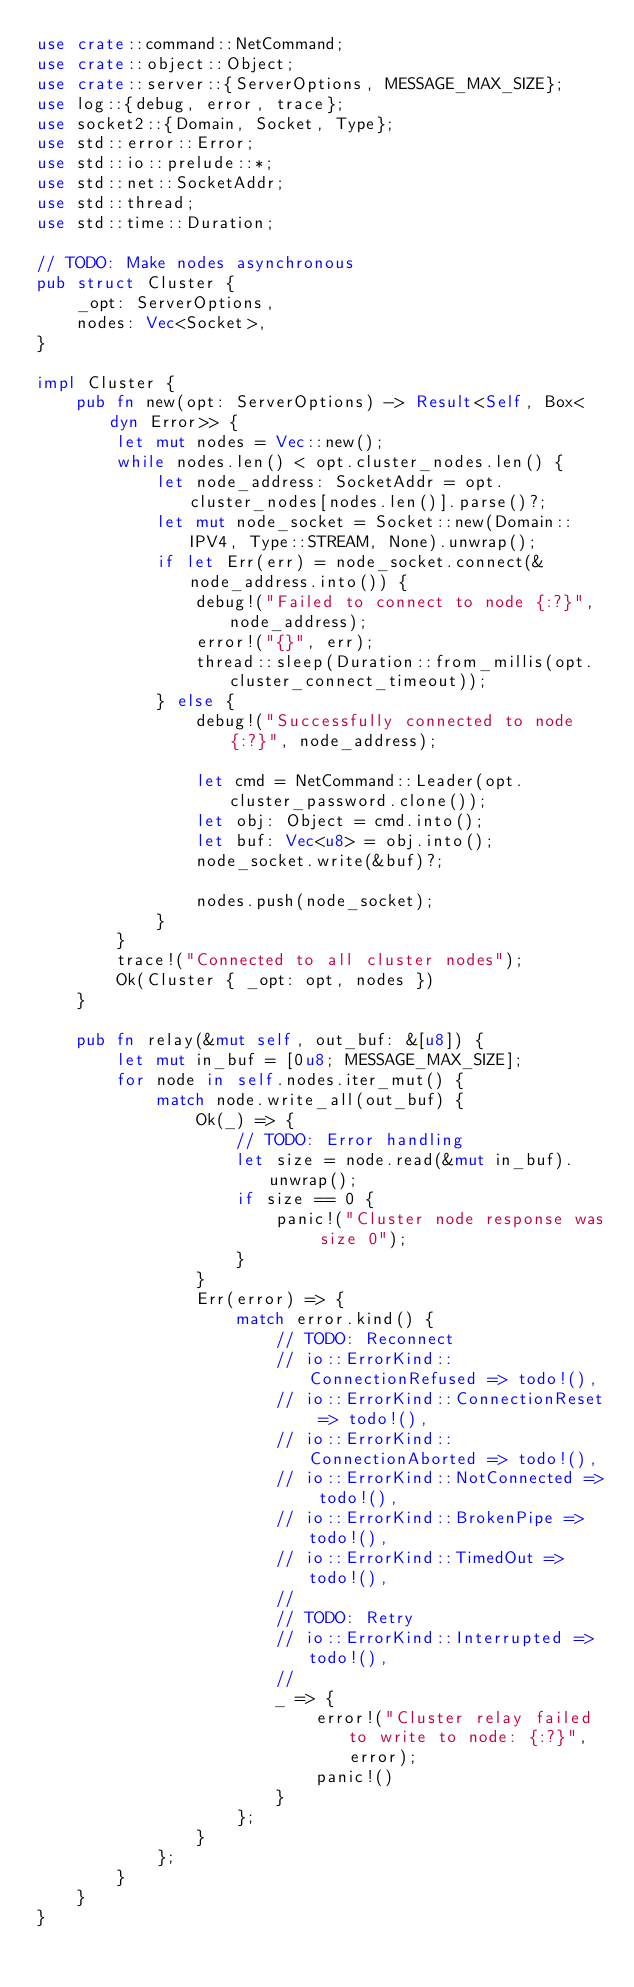Convert code to text. <code><loc_0><loc_0><loc_500><loc_500><_Rust_>use crate::command::NetCommand;
use crate::object::Object;
use crate::server::{ServerOptions, MESSAGE_MAX_SIZE};
use log::{debug, error, trace};
use socket2::{Domain, Socket, Type};
use std::error::Error;
use std::io::prelude::*;
use std::net::SocketAddr;
use std::thread;
use std::time::Duration;

// TODO: Make nodes asynchronous
pub struct Cluster {
    _opt: ServerOptions,
    nodes: Vec<Socket>,
}

impl Cluster {
    pub fn new(opt: ServerOptions) -> Result<Self, Box<dyn Error>> {
        let mut nodes = Vec::new();
        while nodes.len() < opt.cluster_nodes.len() {
            let node_address: SocketAddr = opt.cluster_nodes[nodes.len()].parse()?;
            let mut node_socket = Socket::new(Domain::IPV4, Type::STREAM, None).unwrap();
            if let Err(err) = node_socket.connect(&node_address.into()) {
                debug!("Failed to connect to node {:?}", node_address);
                error!("{}", err);
                thread::sleep(Duration::from_millis(opt.cluster_connect_timeout));
            } else {
                debug!("Successfully connected to node {:?}", node_address);

                let cmd = NetCommand::Leader(opt.cluster_password.clone());
                let obj: Object = cmd.into();
                let buf: Vec<u8> = obj.into();
                node_socket.write(&buf)?;

                nodes.push(node_socket);
            }
        }
        trace!("Connected to all cluster nodes");
        Ok(Cluster { _opt: opt, nodes })
    }

    pub fn relay(&mut self, out_buf: &[u8]) {
        let mut in_buf = [0u8; MESSAGE_MAX_SIZE];
        for node in self.nodes.iter_mut() {
            match node.write_all(out_buf) {
                Ok(_) => {
                    // TODO: Error handling
                    let size = node.read(&mut in_buf).unwrap();
                    if size == 0 {
                        panic!("Cluster node response was size 0");
                    }
                }
                Err(error) => {
                    match error.kind() {
                        // TODO: Reconnect
                        // io::ErrorKind::ConnectionRefused => todo!(),
                        // io::ErrorKind::ConnectionReset => todo!(),
                        // io::ErrorKind::ConnectionAborted => todo!(),
                        // io::ErrorKind::NotConnected => todo!(),
                        // io::ErrorKind::BrokenPipe => todo!(),
                        // io::ErrorKind::TimedOut => todo!(),
                        //
                        // TODO: Retry
                        // io::ErrorKind::Interrupted => todo!(),
                        //
                        _ => {
                            error!("Cluster relay failed to write to node: {:?}", error);
                            panic!()
                        }
                    };
                }
            };
        }
    }
}
</code> 